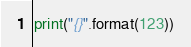<code> <loc_0><loc_0><loc_500><loc_500><_Python_>print("{}".format(123))</code> 